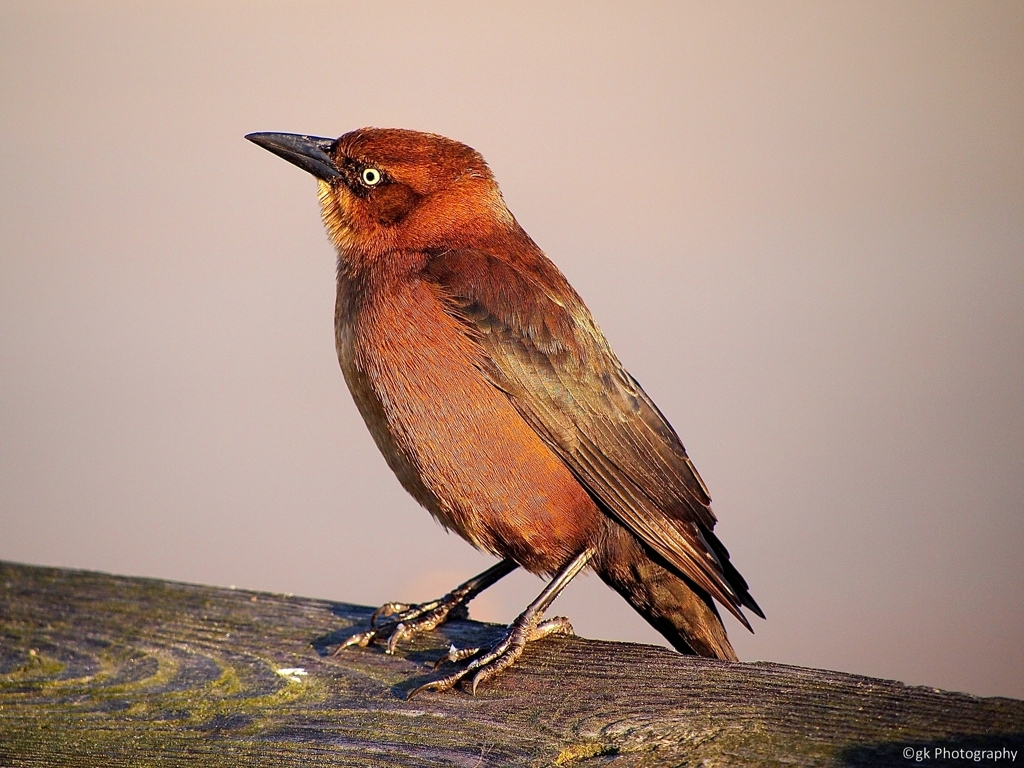What time of day does the lighting suggest this photo was taken? The warm and soft lighting on the bird, along with the long and diffused shadow, suggests that this photo was likely taken during the 'golden hour,' which is shortly after sunrise or before sunset. This time of day offers a flattering natural light that can produce beautiful and vivid photographs with a golden hue. Could you elaborate on how the bird's position affects the overall composition of the image? Certainly. The bird is positioned almost in profile, giving a clear view of its body shape, plumage texture, and eye, which draws the viewer's attention. Its placement to the left side of the frame allows for a balance of negative space to the right, creating a direction for the viewer's gaze to follow and emphasizing the bird as the main subject. The bird's placement also aids in showcasing the texture of the perch it is standing on, adding depth to the composition. 